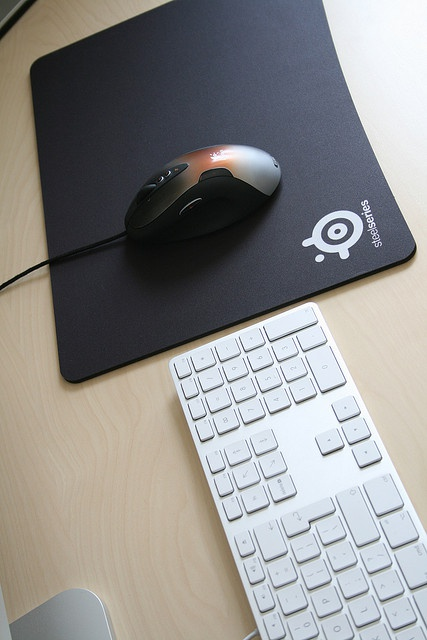Describe the objects in this image and their specific colors. I can see keyboard in black, lightgray, darkgray, and gray tones and mouse in black, gray, lavender, and brown tones in this image. 